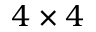Convert formula to latex. <formula><loc_0><loc_0><loc_500><loc_500>4 \times 4</formula> 